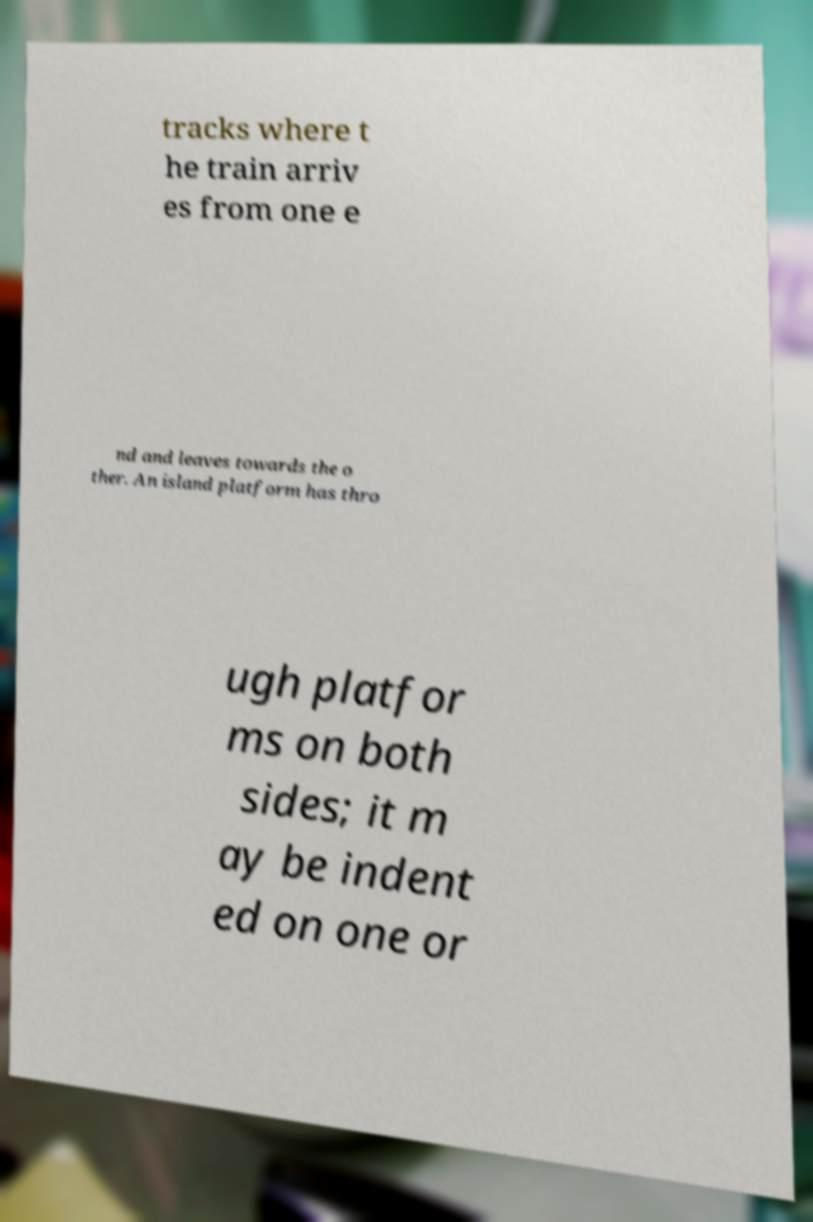What messages or text are displayed in this image? I need them in a readable, typed format. tracks where t he train arriv es from one e nd and leaves towards the o ther. An island platform has thro ugh platfor ms on both sides; it m ay be indent ed on one or 